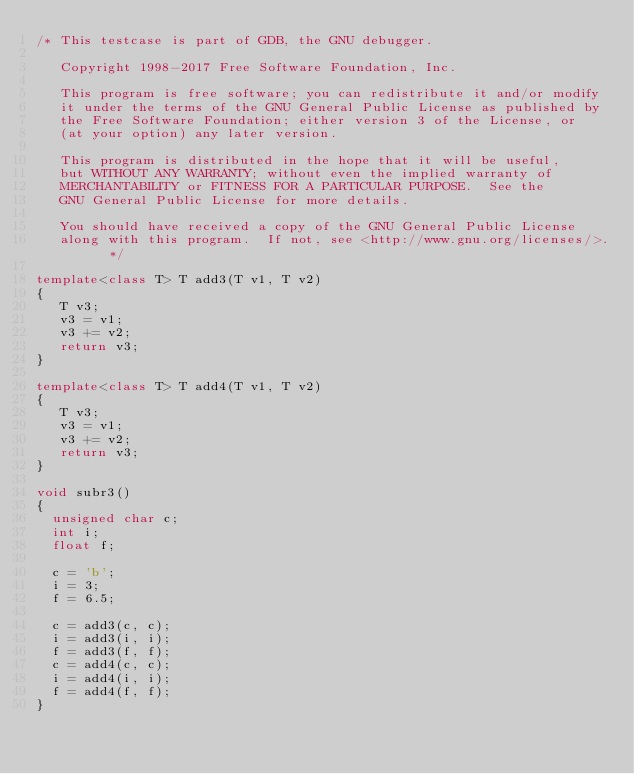<code> <loc_0><loc_0><loc_500><loc_500><_C++_>/* This testcase is part of GDB, the GNU debugger.

   Copyright 1998-2017 Free Software Foundation, Inc.

   This program is free software; you can redistribute it and/or modify
   it under the terms of the GNU General Public License as published by
   the Free Software Foundation; either version 3 of the License, or
   (at your option) any later version.

   This program is distributed in the hope that it will be useful,
   but WITHOUT ANY WARRANTY; without even the implied warranty of
   MERCHANTABILITY or FITNESS FOR A PARTICULAR PURPOSE.  See the
   GNU General Public License for more details.

   You should have received a copy of the GNU General Public License
   along with this program.  If not, see <http://www.gnu.org/licenses/>.  */

template<class T> T add3(T v1, T v2)
{
   T v3;
   v3 = v1;
   v3 += v2;
   return v3;
}

template<class T> T add4(T v1, T v2)
{
   T v3;
   v3 = v1;
   v3 += v2;
   return v3;
}

void subr3()
{
  unsigned char c;
  int i;
  float f;
  
  c = 'b';
  i = 3;
  f = 6.5;

  c = add3(c, c);
  i = add3(i, i);
  f = add3(f, f);
  c = add4(c, c);
  i = add4(i, i);
  f = add4(f, f);
}
</code> 